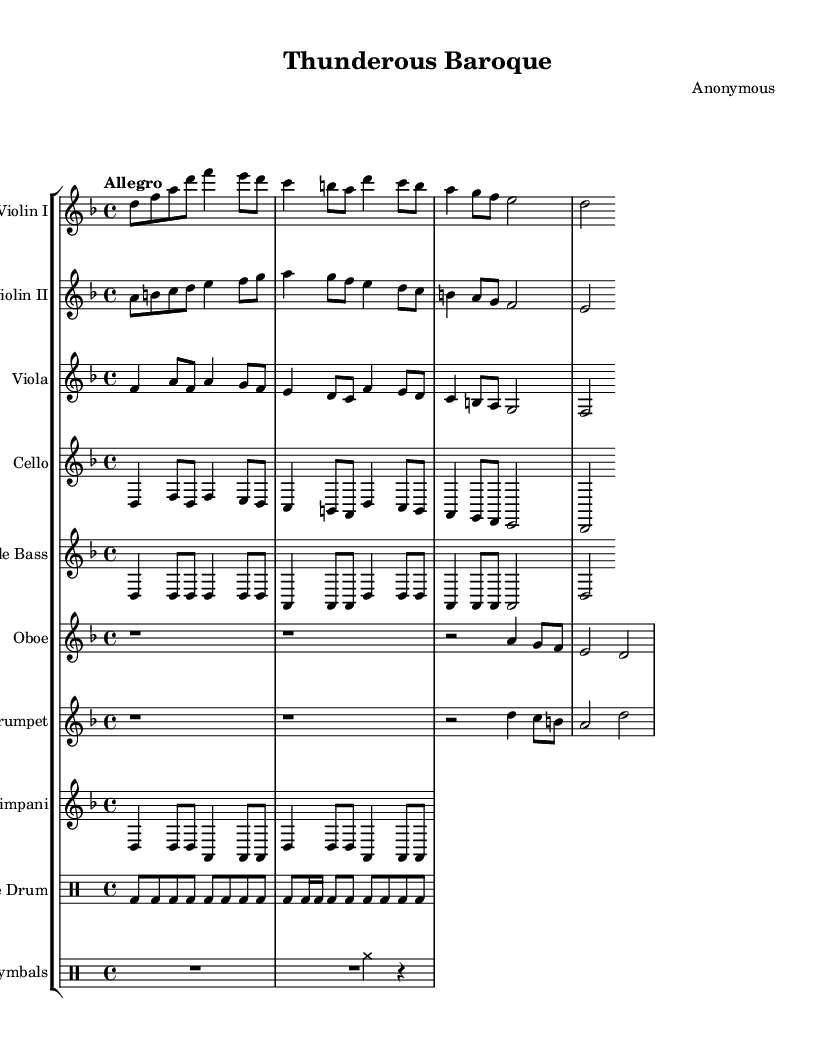What is the key signature of this music? The key signature shown is D minor, indicated by one flat (B flat).
Answer: D minor What is the time signature of the piece? The time signature is at the beginning of the score, showing 4/4, which signifies four beats per measure.
Answer: 4/4 What is the tempo marking for this piece? The tempo marking is indicated as "Allegro," which suggests a fast and lively pace.
Answer: Allegro How many measures does the violin I part contain? By counting the measures in the violin I part, there are four measures as delineated by the bar lines.
Answer: 4 Which instrument has the most prominent role in this orchestral piece? The timpani has a significant and prominent role, marked clearly with specific rhythmic patterns that stand out.
Answer: Timpani What type of percussion is used in this orchestral piece? The percussion instruments included are snare drum and cymbals, as indicated in the score.
Answer: Snare drum and cymbals How does the timpani part contribute to the overall piece? The timpani part reinforces the rhythmic foundation and provides a dramatic accent in the orchestral texture, using repeated notes and rhythmic patterns.
Answer: Dramatic accent 